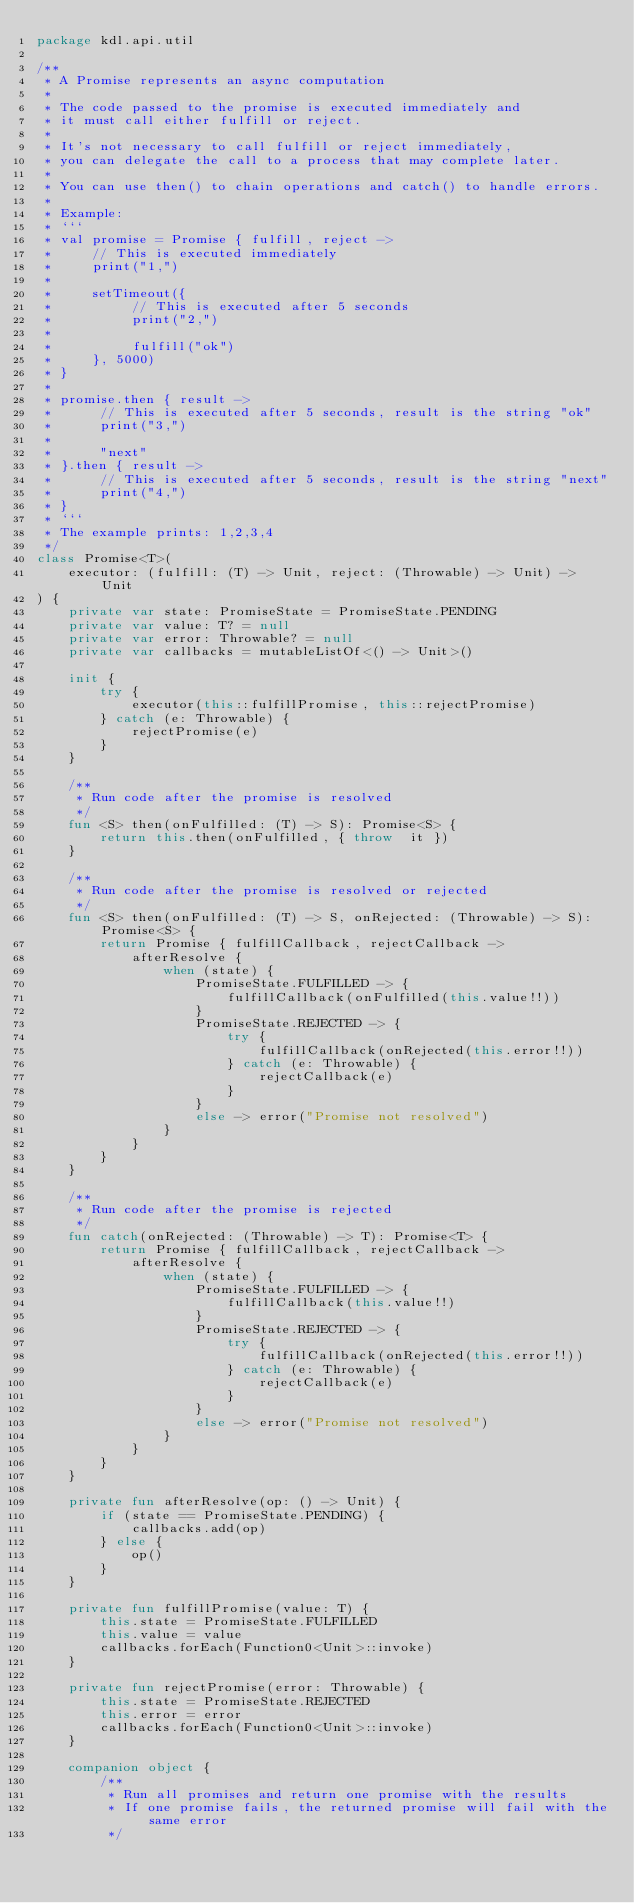<code> <loc_0><loc_0><loc_500><loc_500><_Kotlin_>package kdl.api.util

/**
 * A Promise represents an async computation
 *
 * The code passed to the promise is executed immediately and
 * it must call either fulfill or reject.
 *
 * It's not necessary to call fulfill or reject immediately,
 * you can delegate the call to a process that may complete later.
 *
 * You can use then() to chain operations and catch() to handle errors.
 *
 * Example:
 * ```
 * val promise = Promise { fulfill, reject ->
 *     // This is executed immediately
 *     print("1,")
 *
 *     setTimeout({
 *          // This is executed after 5 seconds
 *          print("2,")
 *
 *          fulfill("ok")
 *     }, 5000)
 * }
 *
 * promise.then { result ->
 *      // This is executed after 5 seconds, result is the string "ok"
 *      print("3,")
 *
 *      "next"
 * }.then { result ->
 *      // This is executed after 5 seconds, result is the string "next"
 *      print("4,")
 * }
 * ```
 * The example prints: 1,2,3,4
 */
class Promise<T>(
    executor: (fulfill: (T) -> Unit, reject: (Throwable) -> Unit) -> Unit
) {
    private var state: PromiseState = PromiseState.PENDING
    private var value: T? = null
    private var error: Throwable? = null
    private var callbacks = mutableListOf<() -> Unit>()

    init {
        try {
            executor(this::fulfillPromise, this::rejectPromise)
        } catch (e: Throwable) {
            rejectPromise(e)
        }
    }

    /**
     * Run code after the promise is resolved
     */
    fun <S> then(onFulfilled: (T) -> S): Promise<S> {
        return this.then(onFulfilled, { throw  it })
    }

    /**
     * Run code after the promise is resolved or rejected
     */
    fun <S> then(onFulfilled: (T) -> S, onRejected: (Throwable) -> S): Promise<S> {
        return Promise { fulfillCallback, rejectCallback ->
            afterResolve {
                when (state) {
                    PromiseState.FULFILLED -> {
                        fulfillCallback(onFulfilled(this.value!!))
                    }
                    PromiseState.REJECTED -> {
                        try {
                            fulfillCallback(onRejected(this.error!!))
                        } catch (e: Throwable) {
                            rejectCallback(e)
                        }
                    }
                    else -> error("Promise not resolved")
                }
            }
        }
    }

    /**
     * Run code after the promise is rejected
     */
    fun catch(onRejected: (Throwable) -> T): Promise<T> {
        return Promise { fulfillCallback, rejectCallback ->
            afterResolve {
                when (state) {
                    PromiseState.FULFILLED -> {
                        fulfillCallback(this.value!!)
                    }
                    PromiseState.REJECTED -> {
                        try {
                            fulfillCallback(onRejected(this.error!!))
                        } catch (e: Throwable) {
                            rejectCallback(e)
                        }
                    }
                    else -> error("Promise not resolved")
                }
            }
        }
    }

    private fun afterResolve(op: () -> Unit) {
        if (state == PromiseState.PENDING) {
            callbacks.add(op)
        } else {
            op()
        }
    }

    private fun fulfillPromise(value: T) {
        this.state = PromiseState.FULFILLED
        this.value = value
        callbacks.forEach(Function0<Unit>::invoke)
    }

    private fun rejectPromise(error: Throwable) {
        this.state = PromiseState.REJECTED
        this.error = error
        callbacks.forEach(Function0<Unit>::invoke)
    }

    companion object {
        /**
         * Run all promises and return one promise with the results
         * If one promise fails, the returned promise will fail with the same error
         */</code> 